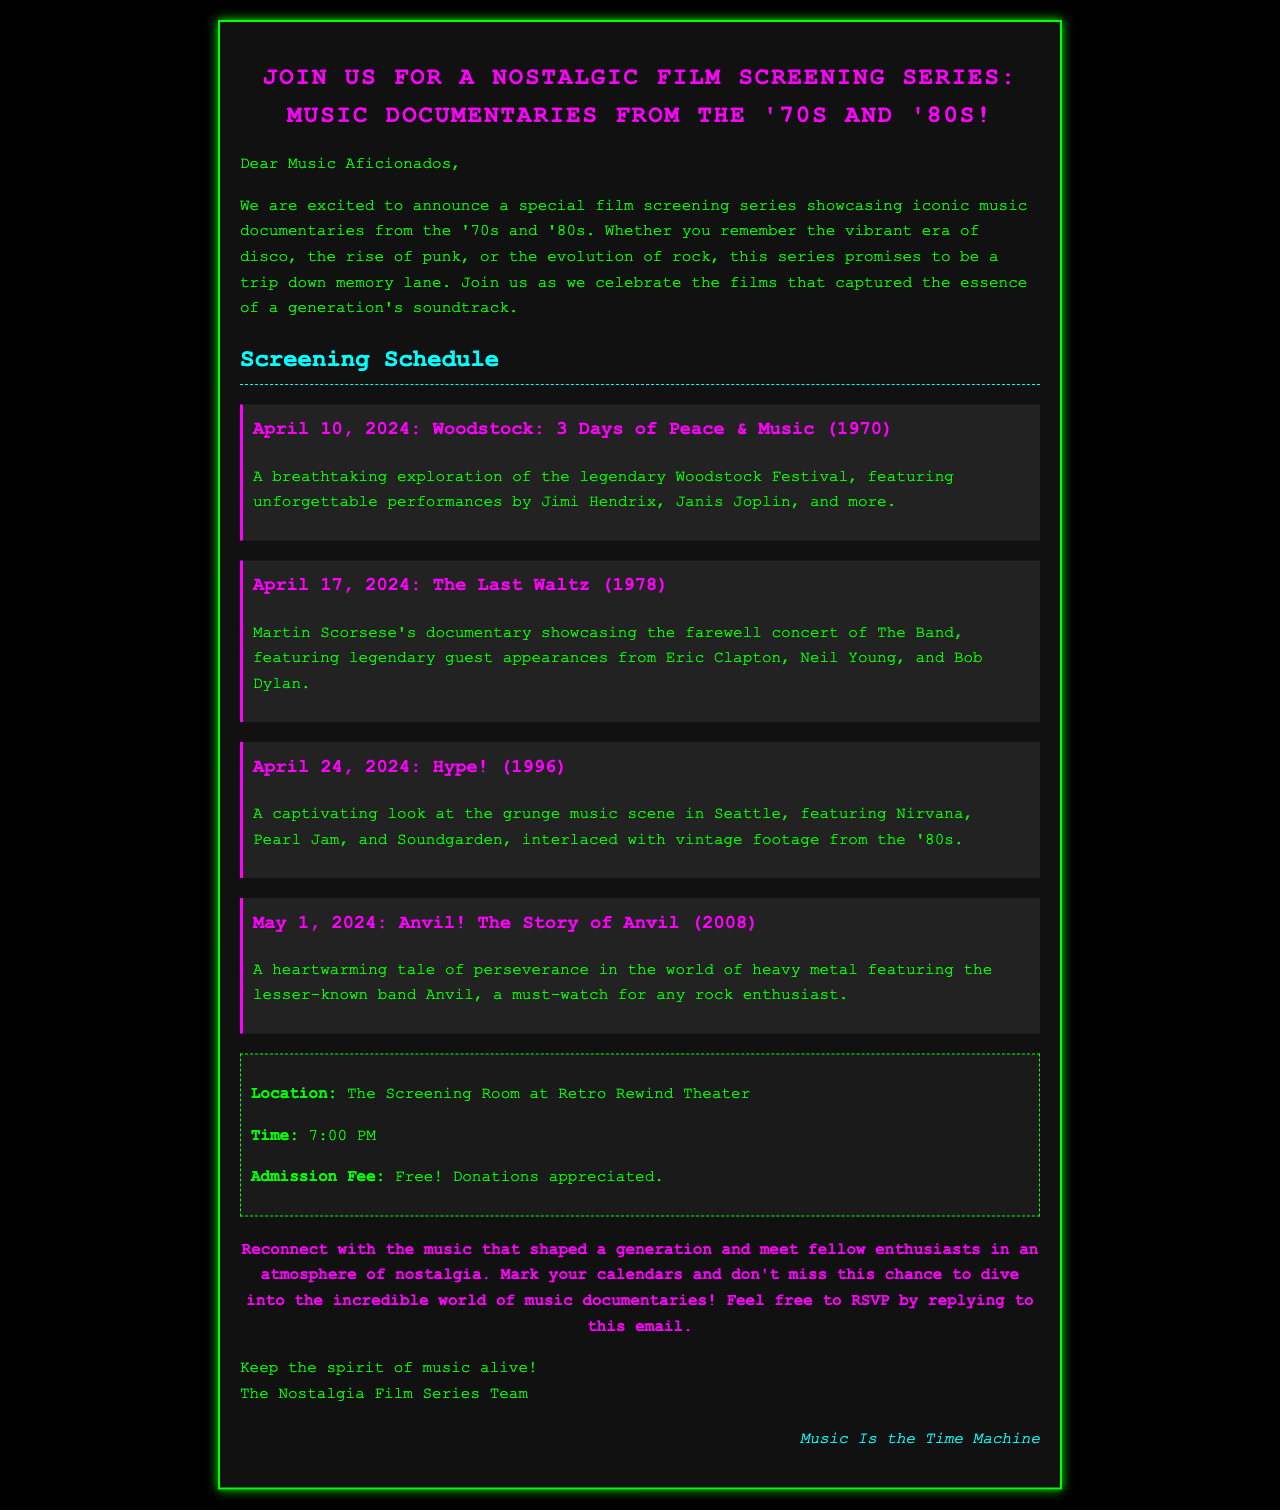What is the title of the film screening series? The title, as stated in the header, is "Join Us for a Nostalgic Film Screening Series: Music Documentaries from the '70s and '80s!"
Answer: Nostalgic Film Screening Series When is the first film screening scheduled? The document states that the first screening is on April 10, 2024.
Answer: April 10, 2024 What is the admission fee for the screenings? In the details section, it's mentioned that the admission fee is free, with donations appreciated.
Answer: Free! Who directed "The Last Waltz"? The email mentions that "The Last Waltz" was directed by Martin Scorsese.
Answer: Martin Scorsese What is the location of the screening series? The location mentioned in the details section is "The Screening Room at Retro Rewind Theater."
Answer: The Screening Room at Retro Rewind Theater What type of documentaries are featured in the series? According to the email, the series features music documentaries.
Answer: Music documentaries Which band was highlighted in the film "Anvil! The Story of Anvil"? The film "Anvil! The Story of Anvil" highlights the lesser-known band Anvil.
Answer: Anvil Which music scene is explored in "Hype!"? The document states that "Hype!" explores the grunge music scene in Seattle.
Answer: Grunge music scene How can attendees RSVP for the event? The email instructs attendees to RSVP by replying to it.
Answer: By replying to this email 